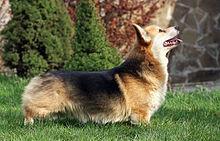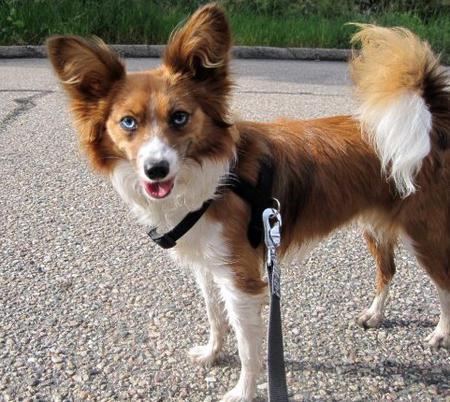The first image is the image on the left, the second image is the image on the right. For the images displayed, is the sentence "The images show a total of two short-legged dogs facing in opposite directions." factually correct? Answer yes or no. No. 